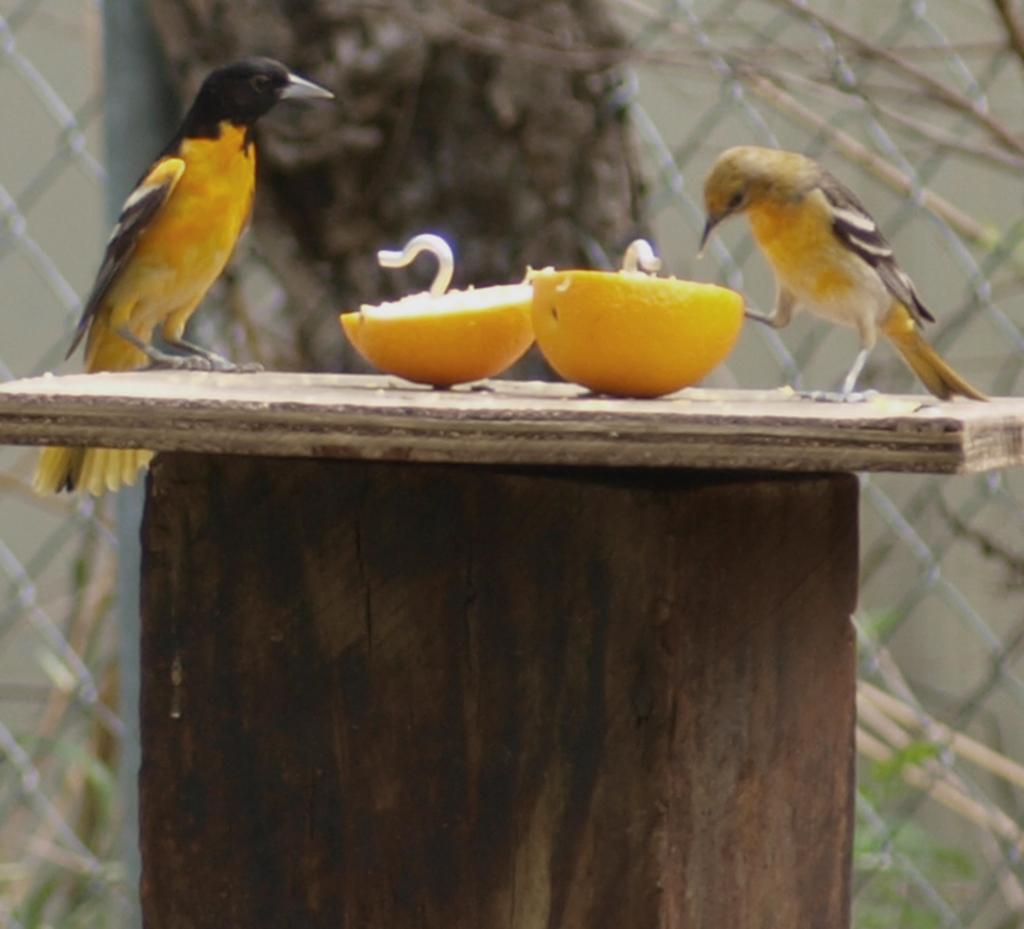What type of animals can be seen in the image? There are birds in the image. What is on the wooden surface in the image? There are food items on a wooden surface in the image. What type of barrier is present in the image? There is a fence in the image. What type of structure is visible in the image? There is a wall in the image. What type of balls are being used for the action in the image? There are no balls or actions involving balls present in the image. 